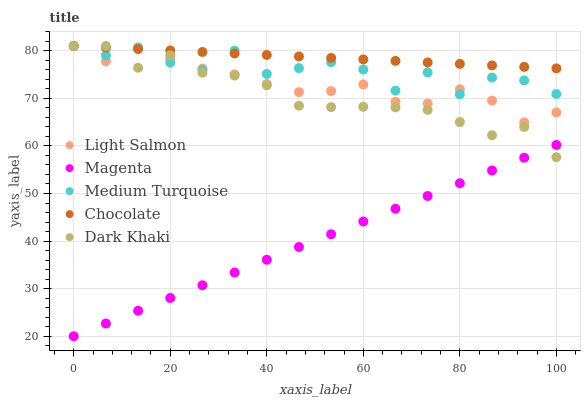Does Magenta have the minimum area under the curve?
Answer yes or no. Yes. Does Chocolate have the maximum area under the curve?
Answer yes or no. Yes. Does Light Salmon have the minimum area under the curve?
Answer yes or no. No. Does Light Salmon have the maximum area under the curve?
Answer yes or no. No. Is Magenta the smoothest?
Answer yes or no. Yes. Is Medium Turquoise the roughest?
Answer yes or no. Yes. Is Light Salmon the smoothest?
Answer yes or no. No. Is Light Salmon the roughest?
Answer yes or no. No. Does Magenta have the lowest value?
Answer yes or no. Yes. Does Light Salmon have the lowest value?
Answer yes or no. No. Does Chocolate have the highest value?
Answer yes or no. Yes. Does Magenta have the highest value?
Answer yes or no. No. Is Magenta less than Chocolate?
Answer yes or no. Yes. Is Light Salmon greater than Magenta?
Answer yes or no. Yes. Does Dark Khaki intersect Chocolate?
Answer yes or no. Yes. Is Dark Khaki less than Chocolate?
Answer yes or no. No. Is Dark Khaki greater than Chocolate?
Answer yes or no. No. Does Magenta intersect Chocolate?
Answer yes or no. No. 